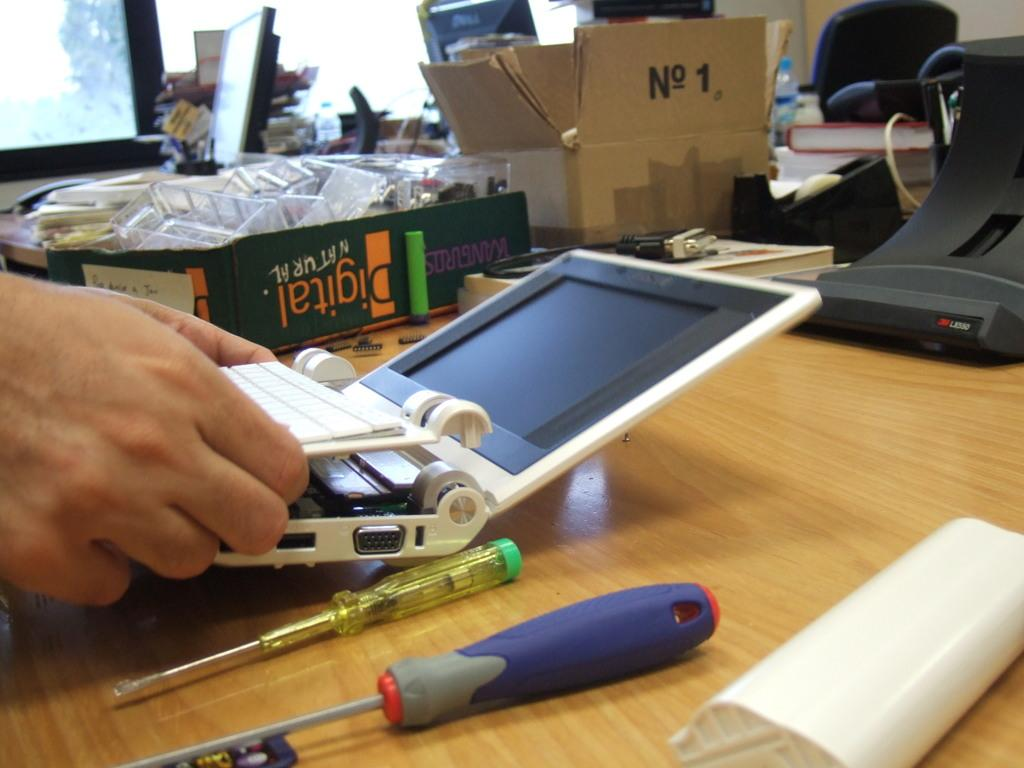<image>
Describe the image concisely. Someone works on a partially assembled laptop computer on a table in front of a box that says Digital natural. 